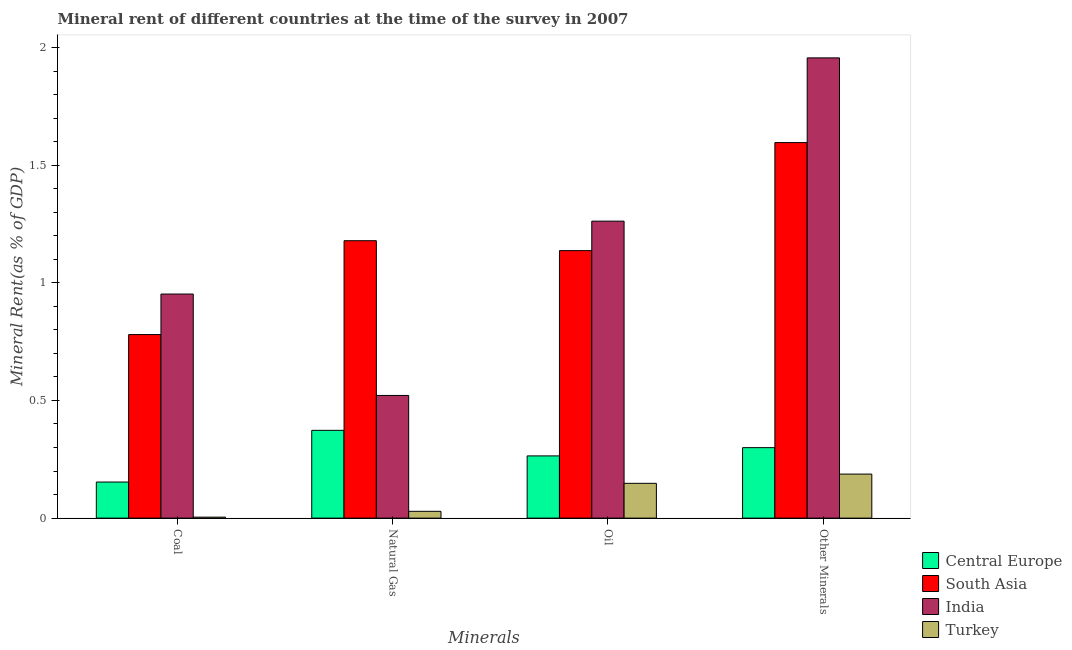How many bars are there on the 2nd tick from the right?
Your response must be concise. 4. What is the label of the 3rd group of bars from the left?
Provide a short and direct response. Oil. What is the  rent of other minerals in Central Europe?
Provide a short and direct response. 0.3. Across all countries, what is the maximum  rent of other minerals?
Provide a succinct answer. 1.96. Across all countries, what is the minimum natural gas rent?
Provide a short and direct response. 0.03. In which country was the oil rent minimum?
Provide a short and direct response. Turkey. What is the total oil rent in the graph?
Provide a short and direct response. 2.81. What is the difference between the oil rent in South Asia and that in Turkey?
Provide a succinct answer. 0.99. What is the difference between the coal rent in Turkey and the natural gas rent in Central Europe?
Your answer should be very brief. -0.37. What is the average coal rent per country?
Provide a succinct answer. 0.47. What is the difference between the oil rent and coal rent in South Asia?
Your answer should be very brief. 0.36. In how many countries, is the natural gas rent greater than 0.4 %?
Make the answer very short. 2. What is the ratio of the natural gas rent in Central Europe to that in South Asia?
Provide a succinct answer. 0.32. Is the oil rent in South Asia less than that in Turkey?
Provide a short and direct response. No. What is the difference between the highest and the second highest natural gas rent?
Make the answer very short. 0.66. What is the difference between the highest and the lowest  rent of other minerals?
Your answer should be very brief. 1.77. In how many countries, is the coal rent greater than the average coal rent taken over all countries?
Ensure brevity in your answer.  2. What does the 1st bar from the right in Coal represents?
Your answer should be compact. Turkey. What is the difference between two consecutive major ticks on the Y-axis?
Your response must be concise. 0.5. Does the graph contain grids?
Provide a succinct answer. No. Where does the legend appear in the graph?
Your response must be concise. Bottom right. What is the title of the graph?
Ensure brevity in your answer.  Mineral rent of different countries at the time of the survey in 2007. What is the label or title of the X-axis?
Offer a very short reply. Minerals. What is the label or title of the Y-axis?
Offer a terse response. Mineral Rent(as % of GDP). What is the Mineral Rent(as % of GDP) of Central Europe in Coal?
Your answer should be very brief. 0.15. What is the Mineral Rent(as % of GDP) of South Asia in Coal?
Offer a very short reply. 0.78. What is the Mineral Rent(as % of GDP) in India in Coal?
Keep it short and to the point. 0.95. What is the Mineral Rent(as % of GDP) of Turkey in Coal?
Give a very brief answer. 0. What is the Mineral Rent(as % of GDP) in Central Europe in Natural Gas?
Offer a very short reply. 0.37. What is the Mineral Rent(as % of GDP) in South Asia in Natural Gas?
Your answer should be very brief. 1.18. What is the Mineral Rent(as % of GDP) of India in Natural Gas?
Offer a very short reply. 0.52. What is the Mineral Rent(as % of GDP) of Turkey in Natural Gas?
Make the answer very short. 0.03. What is the Mineral Rent(as % of GDP) of Central Europe in Oil?
Offer a terse response. 0.26. What is the Mineral Rent(as % of GDP) of South Asia in Oil?
Provide a short and direct response. 1.14. What is the Mineral Rent(as % of GDP) of India in Oil?
Give a very brief answer. 1.26. What is the Mineral Rent(as % of GDP) of Turkey in Oil?
Your answer should be compact. 0.15. What is the Mineral Rent(as % of GDP) in Central Europe in Other Minerals?
Keep it short and to the point. 0.3. What is the Mineral Rent(as % of GDP) in South Asia in Other Minerals?
Make the answer very short. 1.6. What is the Mineral Rent(as % of GDP) of India in Other Minerals?
Provide a short and direct response. 1.96. What is the Mineral Rent(as % of GDP) of Turkey in Other Minerals?
Your answer should be compact. 0.19. Across all Minerals, what is the maximum Mineral Rent(as % of GDP) of Central Europe?
Offer a very short reply. 0.37. Across all Minerals, what is the maximum Mineral Rent(as % of GDP) in South Asia?
Offer a very short reply. 1.6. Across all Minerals, what is the maximum Mineral Rent(as % of GDP) in India?
Make the answer very short. 1.96. Across all Minerals, what is the maximum Mineral Rent(as % of GDP) in Turkey?
Your answer should be very brief. 0.19. Across all Minerals, what is the minimum Mineral Rent(as % of GDP) in Central Europe?
Your response must be concise. 0.15. Across all Minerals, what is the minimum Mineral Rent(as % of GDP) in South Asia?
Offer a terse response. 0.78. Across all Minerals, what is the minimum Mineral Rent(as % of GDP) of India?
Offer a terse response. 0.52. Across all Minerals, what is the minimum Mineral Rent(as % of GDP) of Turkey?
Ensure brevity in your answer.  0. What is the total Mineral Rent(as % of GDP) of Central Europe in the graph?
Ensure brevity in your answer.  1.09. What is the total Mineral Rent(as % of GDP) of South Asia in the graph?
Give a very brief answer. 4.69. What is the total Mineral Rent(as % of GDP) of India in the graph?
Provide a succinct answer. 4.69. What is the total Mineral Rent(as % of GDP) in Turkey in the graph?
Provide a short and direct response. 0.37. What is the difference between the Mineral Rent(as % of GDP) of Central Europe in Coal and that in Natural Gas?
Your response must be concise. -0.22. What is the difference between the Mineral Rent(as % of GDP) of South Asia in Coal and that in Natural Gas?
Provide a short and direct response. -0.4. What is the difference between the Mineral Rent(as % of GDP) in India in Coal and that in Natural Gas?
Provide a succinct answer. 0.43. What is the difference between the Mineral Rent(as % of GDP) in Turkey in Coal and that in Natural Gas?
Ensure brevity in your answer.  -0.02. What is the difference between the Mineral Rent(as % of GDP) of Central Europe in Coal and that in Oil?
Provide a short and direct response. -0.11. What is the difference between the Mineral Rent(as % of GDP) in South Asia in Coal and that in Oil?
Your answer should be compact. -0.36. What is the difference between the Mineral Rent(as % of GDP) of India in Coal and that in Oil?
Offer a very short reply. -0.31. What is the difference between the Mineral Rent(as % of GDP) of Turkey in Coal and that in Oil?
Offer a terse response. -0.14. What is the difference between the Mineral Rent(as % of GDP) in Central Europe in Coal and that in Other Minerals?
Make the answer very short. -0.15. What is the difference between the Mineral Rent(as % of GDP) in South Asia in Coal and that in Other Minerals?
Ensure brevity in your answer.  -0.82. What is the difference between the Mineral Rent(as % of GDP) of India in Coal and that in Other Minerals?
Offer a terse response. -1. What is the difference between the Mineral Rent(as % of GDP) of Turkey in Coal and that in Other Minerals?
Your response must be concise. -0.18. What is the difference between the Mineral Rent(as % of GDP) of Central Europe in Natural Gas and that in Oil?
Provide a succinct answer. 0.11. What is the difference between the Mineral Rent(as % of GDP) of South Asia in Natural Gas and that in Oil?
Ensure brevity in your answer.  0.04. What is the difference between the Mineral Rent(as % of GDP) of India in Natural Gas and that in Oil?
Provide a succinct answer. -0.74. What is the difference between the Mineral Rent(as % of GDP) in Turkey in Natural Gas and that in Oil?
Give a very brief answer. -0.12. What is the difference between the Mineral Rent(as % of GDP) of Central Europe in Natural Gas and that in Other Minerals?
Give a very brief answer. 0.07. What is the difference between the Mineral Rent(as % of GDP) of South Asia in Natural Gas and that in Other Minerals?
Give a very brief answer. -0.42. What is the difference between the Mineral Rent(as % of GDP) of India in Natural Gas and that in Other Minerals?
Ensure brevity in your answer.  -1.43. What is the difference between the Mineral Rent(as % of GDP) of Turkey in Natural Gas and that in Other Minerals?
Offer a terse response. -0.16. What is the difference between the Mineral Rent(as % of GDP) in Central Europe in Oil and that in Other Minerals?
Make the answer very short. -0.04. What is the difference between the Mineral Rent(as % of GDP) in South Asia in Oil and that in Other Minerals?
Your answer should be compact. -0.46. What is the difference between the Mineral Rent(as % of GDP) in India in Oil and that in Other Minerals?
Offer a terse response. -0.69. What is the difference between the Mineral Rent(as % of GDP) of Turkey in Oil and that in Other Minerals?
Offer a very short reply. -0.04. What is the difference between the Mineral Rent(as % of GDP) of Central Europe in Coal and the Mineral Rent(as % of GDP) of South Asia in Natural Gas?
Offer a very short reply. -1.03. What is the difference between the Mineral Rent(as % of GDP) in Central Europe in Coal and the Mineral Rent(as % of GDP) in India in Natural Gas?
Provide a short and direct response. -0.37. What is the difference between the Mineral Rent(as % of GDP) in Central Europe in Coal and the Mineral Rent(as % of GDP) in Turkey in Natural Gas?
Your answer should be very brief. 0.12. What is the difference between the Mineral Rent(as % of GDP) of South Asia in Coal and the Mineral Rent(as % of GDP) of India in Natural Gas?
Provide a succinct answer. 0.26. What is the difference between the Mineral Rent(as % of GDP) in South Asia in Coal and the Mineral Rent(as % of GDP) in Turkey in Natural Gas?
Offer a terse response. 0.75. What is the difference between the Mineral Rent(as % of GDP) in India in Coal and the Mineral Rent(as % of GDP) in Turkey in Natural Gas?
Provide a short and direct response. 0.92. What is the difference between the Mineral Rent(as % of GDP) of Central Europe in Coal and the Mineral Rent(as % of GDP) of South Asia in Oil?
Provide a short and direct response. -0.98. What is the difference between the Mineral Rent(as % of GDP) in Central Europe in Coal and the Mineral Rent(as % of GDP) in India in Oil?
Your response must be concise. -1.11. What is the difference between the Mineral Rent(as % of GDP) in Central Europe in Coal and the Mineral Rent(as % of GDP) in Turkey in Oil?
Your response must be concise. 0.01. What is the difference between the Mineral Rent(as % of GDP) of South Asia in Coal and the Mineral Rent(as % of GDP) of India in Oil?
Your answer should be very brief. -0.48. What is the difference between the Mineral Rent(as % of GDP) of South Asia in Coal and the Mineral Rent(as % of GDP) of Turkey in Oil?
Give a very brief answer. 0.63. What is the difference between the Mineral Rent(as % of GDP) of India in Coal and the Mineral Rent(as % of GDP) of Turkey in Oil?
Provide a succinct answer. 0.8. What is the difference between the Mineral Rent(as % of GDP) in Central Europe in Coal and the Mineral Rent(as % of GDP) in South Asia in Other Minerals?
Your response must be concise. -1.44. What is the difference between the Mineral Rent(as % of GDP) of Central Europe in Coal and the Mineral Rent(as % of GDP) of India in Other Minerals?
Provide a short and direct response. -1.8. What is the difference between the Mineral Rent(as % of GDP) of Central Europe in Coal and the Mineral Rent(as % of GDP) of Turkey in Other Minerals?
Provide a succinct answer. -0.03. What is the difference between the Mineral Rent(as % of GDP) in South Asia in Coal and the Mineral Rent(as % of GDP) in India in Other Minerals?
Give a very brief answer. -1.18. What is the difference between the Mineral Rent(as % of GDP) in South Asia in Coal and the Mineral Rent(as % of GDP) in Turkey in Other Minerals?
Your answer should be compact. 0.59. What is the difference between the Mineral Rent(as % of GDP) in India in Coal and the Mineral Rent(as % of GDP) in Turkey in Other Minerals?
Offer a terse response. 0.77. What is the difference between the Mineral Rent(as % of GDP) of Central Europe in Natural Gas and the Mineral Rent(as % of GDP) of South Asia in Oil?
Offer a very short reply. -0.76. What is the difference between the Mineral Rent(as % of GDP) of Central Europe in Natural Gas and the Mineral Rent(as % of GDP) of India in Oil?
Offer a very short reply. -0.89. What is the difference between the Mineral Rent(as % of GDP) of Central Europe in Natural Gas and the Mineral Rent(as % of GDP) of Turkey in Oil?
Make the answer very short. 0.23. What is the difference between the Mineral Rent(as % of GDP) of South Asia in Natural Gas and the Mineral Rent(as % of GDP) of India in Oil?
Offer a terse response. -0.08. What is the difference between the Mineral Rent(as % of GDP) of South Asia in Natural Gas and the Mineral Rent(as % of GDP) of Turkey in Oil?
Offer a terse response. 1.03. What is the difference between the Mineral Rent(as % of GDP) in India in Natural Gas and the Mineral Rent(as % of GDP) in Turkey in Oil?
Ensure brevity in your answer.  0.37. What is the difference between the Mineral Rent(as % of GDP) in Central Europe in Natural Gas and the Mineral Rent(as % of GDP) in South Asia in Other Minerals?
Offer a very short reply. -1.22. What is the difference between the Mineral Rent(as % of GDP) of Central Europe in Natural Gas and the Mineral Rent(as % of GDP) of India in Other Minerals?
Make the answer very short. -1.58. What is the difference between the Mineral Rent(as % of GDP) of Central Europe in Natural Gas and the Mineral Rent(as % of GDP) of Turkey in Other Minerals?
Offer a terse response. 0.19. What is the difference between the Mineral Rent(as % of GDP) of South Asia in Natural Gas and the Mineral Rent(as % of GDP) of India in Other Minerals?
Your response must be concise. -0.78. What is the difference between the Mineral Rent(as % of GDP) in India in Natural Gas and the Mineral Rent(as % of GDP) in Turkey in Other Minerals?
Make the answer very short. 0.33. What is the difference between the Mineral Rent(as % of GDP) in Central Europe in Oil and the Mineral Rent(as % of GDP) in South Asia in Other Minerals?
Make the answer very short. -1.33. What is the difference between the Mineral Rent(as % of GDP) of Central Europe in Oil and the Mineral Rent(as % of GDP) of India in Other Minerals?
Give a very brief answer. -1.69. What is the difference between the Mineral Rent(as % of GDP) in Central Europe in Oil and the Mineral Rent(as % of GDP) in Turkey in Other Minerals?
Provide a short and direct response. 0.08. What is the difference between the Mineral Rent(as % of GDP) of South Asia in Oil and the Mineral Rent(as % of GDP) of India in Other Minerals?
Ensure brevity in your answer.  -0.82. What is the difference between the Mineral Rent(as % of GDP) in South Asia in Oil and the Mineral Rent(as % of GDP) in Turkey in Other Minerals?
Offer a terse response. 0.95. What is the difference between the Mineral Rent(as % of GDP) in India in Oil and the Mineral Rent(as % of GDP) in Turkey in Other Minerals?
Make the answer very short. 1.07. What is the average Mineral Rent(as % of GDP) of Central Europe per Minerals?
Provide a short and direct response. 0.27. What is the average Mineral Rent(as % of GDP) of South Asia per Minerals?
Your response must be concise. 1.17. What is the average Mineral Rent(as % of GDP) in India per Minerals?
Keep it short and to the point. 1.17. What is the average Mineral Rent(as % of GDP) in Turkey per Minerals?
Offer a very short reply. 0.09. What is the difference between the Mineral Rent(as % of GDP) in Central Europe and Mineral Rent(as % of GDP) in South Asia in Coal?
Your answer should be compact. -0.63. What is the difference between the Mineral Rent(as % of GDP) of Central Europe and Mineral Rent(as % of GDP) of India in Coal?
Offer a terse response. -0.8. What is the difference between the Mineral Rent(as % of GDP) in Central Europe and Mineral Rent(as % of GDP) in Turkey in Coal?
Keep it short and to the point. 0.15. What is the difference between the Mineral Rent(as % of GDP) of South Asia and Mineral Rent(as % of GDP) of India in Coal?
Your response must be concise. -0.17. What is the difference between the Mineral Rent(as % of GDP) in South Asia and Mineral Rent(as % of GDP) in Turkey in Coal?
Offer a terse response. 0.78. What is the difference between the Mineral Rent(as % of GDP) of India and Mineral Rent(as % of GDP) of Turkey in Coal?
Offer a very short reply. 0.95. What is the difference between the Mineral Rent(as % of GDP) in Central Europe and Mineral Rent(as % of GDP) in South Asia in Natural Gas?
Ensure brevity in your answer.  -0.81. What is the difference between the Mineral Rent(as % of GDP) of Central Europe and Mineral Rent(as % of GDP) of India in Natural Gas?
Offer a terse response. -0.15. What is the difference between the Mineral Rent(as % of GDP) of Central Europe and Mineral Rent(as % of GDP) of Turkey in Natural Gas?
Offer a very short reply. 0.34. What is the difference between the Mineral Rent(as % of GDP) of South Asia and Mineral Rent(as % of GDP) of India in Natural Gas?
Provide a short and direct response. 0.66. What is the difference between the Mineral Rent(as % of GDP) of South Asia and Mineral Rent(as % of GDP) of Turkey in Natural Gas?
Provide a short and direct response. 1.15. What is the difference between the Mineral Rent(as % of GDP) in India and Mineral Rent(as % of GDP) in Turkey in Natural Gas?
Ensure brevity in your answer.  0.49. What is the difference between the Mineral Rent(as % of GDP) in Central Europe and Mineral Rent(as % of GDP) in South Asia in Oil?
Offer a terse response. -0.87. What is the difference between the Mineral Rent(as % of GDP) of Central Europe and Mineral Rent(as % of GDP) of India in Oil?
Ensure brevity in your answer.  -1. What is the difference between the Mineral Rent(as % of GDP) in Central Europe and Mineral Rent(as % of GDP) in Turkey in Oil?
Your response must be concise. 0.12. What is the difference between the Mineral Rent(as % of GDP) in South Asia and Mineral Rent(as % of GDP) in India in Oil?
Ensure brevity in your answer.  -0.13. What is the difference between the Mineral Rent(as % of GDP) of South Asia and Mineral Rent(as % of GDP) of Turkey in Oil?
Keep it short and to the point. 0.99. What is the difference between the Mineral Rent(as % of GDP) of India and Mineral Rent(as % of GDP) of Turkey in Oil?
Ensure brevity in your answer.  1.11. What is the difference between the Mineral Rent(as % of GDP) of Central Europe and Mineral Rent(as % of GDP) of South Asia in Other Minerals?
Give a very brief answer. -1.3. What is the difference between the Mineral Rent(as % of GDP) of Central Europe and Mineral Rent(as % of GDP) of India in Other Minerals?
Make the answer very short. -1.66. What is the difference between the Mineral Rent(as % of GDP) in Central Europe and Mineral Rent(as % of GDP) in Turkey in Other Minerals?
Your answer should be compact. 0.11. What is the difference between the Mineral Rent(as % of GDP) in South Asia and Mineral Rent(as % of GDP) in India in Other Minerals?
Give a very brief answer. -0.36. What is the difference between the Mineral Rent(as % of GDP) in South Asia and Mineral Rent(as % of GDP) in Turkey in Other Minerals?
Your answer should be compact. 1.41. What is the difference between the Mineral Rent(as % of GDP) of India and Mineral Rent(as % of GDP) of Turkey in Other Minerals?
Provide a short and direct response. 1.77. What is the ratio of the Mineral Rent(as % of GDP) of Central Europe in Coal to that in Natural Gas?
Ensure brevity in your answer.  0.41. What is the ratio of the Mineral Rent(as % of GDP) in South Asia in Coal to that in Natural Gas?
Provide a succinct answer. 0.66. What is the ratio of the Mineral Rent(as % of GDP) of India in Coal to that in Natural Gas?
Ensure brevity in your answer.  1.83. What is the ratio of the Mineral Rent(as % of GDP) of Turkey in Coal to that in Natural Gas?
Your response must be concise. 0.14. What is the ratio of the Mineral Rent(as % of GDP) in Central Europe in Coal to that in Oil?
Your answer should be very brief. 0.58. What is the ratio of the Mineral Rent(as % of GDP) of South Asia in Coal to that in Oil?
Provide a succinct answer. 0.69. What is the ratio of the Mineral Rent(as % of GDP) in India in Coal to that in Oil?
Your answer should be very brief. 0.75. What is the ratio of the Mineral Rent(as % of GDP) in Turkey in Coal to that in Oil?
Make the answer very short. 0.03. What is the ratio of the Mineral Rent(as % of GDP) of Central Europe in Coal to that in Other Minerals?
Your response must be concise. 0.51. What is the ratio of the Mineral Rent(as % of GDP) in South Asia in Coal to that in Other Minerals?
Make the answer very short. 0.49. What is the ratio of the Mineral Rent(as % of GDP) of India in Coal to that in Other Minerals?
Offer a terse response. 0.49. What is the ratio of the Mineral Rent(as % of GDP) in Turkey in Coal to that in Other Minerals?
Your response must be concise. 0.02. What is the ratio of the Mineral Rent(as % of GDP) in Central Europe in Natural Gas to that in Oil?
Provide a succinct answer. 1.41. What is the ratio of the Mineral Rent(as % of GDP) in South Asia in Natural Gas to that in Oil?
Offer a terse response. 1.04. What is the ratio of the Mineral Rent(as % of GDP) of India in Natural Gas to that in Oil?
Keep it short and to the point. 0.41. What is the ratio of the Mineral Rent(as % of GDP) of Turkey in Natural Gas to that in Oil?
Keep it short and to the point. 0.2. What is the ratio of the Mineral Rent(as % of GDP) of Central Europe in Natural Gas to that in Other Minerals?
Keep it short and to the point. 1.25. What is the ratio of the Mineral Rent(as % of GDP) in South Asia in Natural Gas to that in Other Minerals?
Offer a very short reply. 0.74. What is the ratio of the Mineral Rent(as % of GDP) in India in Natural Gas to that in Other Minerals?
Provide a succinct answer. 0.27. What is the ratio of the Mineral Rent(as % of GDP) in Turkey in Natural Gas to that in Other Minerals?
Provide a succinct answer. 0.15. What is the ratio of the Mineral Rent(as % of GDP) of Central Europe in Oil to that in Other Minerals?
Offer a very short reply. 0.88. What is the ratio of the Mineral Rent(as % of GDP) in South Asia in Oil to that in Other Minerals?
Make the answer very short. 0.71. What is the ratio of the Mineral Rent(as % of GDP) in India in Oil to that in Other Minerals?
Your answer should be compact. 0.65. What is the ratio of the Mineral Rent(as % of GDP) in Turkey in Oil to that in Other Minerals?
Your answer should be very brief. 0.79. What is the difference between the highest and the second highest Mineral Rent(as % of GDP) in Central Europe?
Give a very brief answer. 0.07. What is the difference between the highest and the second highest Mineral Rent(as % of GDP) in South Asia?
Ensure brevity in your answer.  0.42. What is the difference between the highest and the second highest Mineral Rent(as % of GDP) of India?
Your answer should be compact. 0.69. What is the difference between the highest and the second highest Mineral Rent(as % of GDP) in Turkey?
Your answer should be very brief. 0.04. What is the difference between the highest and the lowest Mineral Rent(as % of GDP) in Central Europe?
Your answer should be compact. 0.22. What is the difference between the highest and the lowest Mineral Rent(as % of GDP) of South Asia?
Offer a terse response. 0.82. What is the difference between the highest and the lowest Mineral Rent(as % of GDP) in India?
Give a very brief answer. 1.43. What is the difference between the highest and the lowest Mineral Rent(as % of GDP) in Turkey?
Make the answer very short. 0.18. 